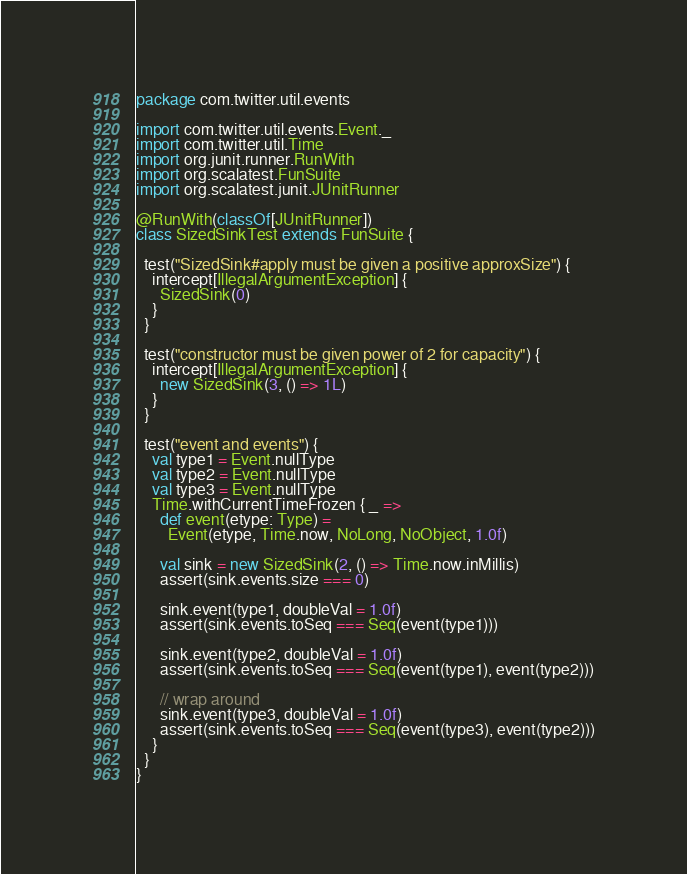<code> <loc_0><loc_0><loc_500><loc_500><_Scala_>package com.twitter.util.events

import com.twitter.util.events.Event._
import com.twitter.util.Time
import org.junit.runner.RunWith
import org.scalatest.FunSuite
import org.scalatest.junit.JUnitRunner

@RunWith(classOf[JUnitRunner])
class SizedSinkTest extends FunSuite {

  test("SizedSink#apply must be given a positive approxSize") {
    intercept[IllegalArgumentException] {
      SizedSink(0)
    }
  }

  test("constructor must be given power of 2 for capacity") {
    intercept[IllegalArgumentException] {
      new SizedSink(3, () => 1L)
    }
  }

  test("event and events") {
    val type1 = Event.nullType
    val type2 = Event.nullType
    val type3 = Event.nullType
    Time.withCurrentTimeFrozen { _ =>
      def event(etype: Type) =
        Event(etype, Time.now, NoLong, NoObject, 1.0f)

      val sink = new SizedSink(2, () => Time.now.inMillis)
      assert(sink.events.size === 0)

      sink.event(type1, doubleVal = 1.0f)
      assert(sink.events.toSeq === Seq(event(type1)))

      sink.event(type2, doubleVal = 1.0f)
      assert(sink.events.toSeq === Seq(event(type1), event(type2)))

      // wrap around
      sink.event(type3, doubleVal = 1.0f)
      assert(sink.events.toSeq === Seq(event(type3), event(type2)))
    }
  }
}
</code> 